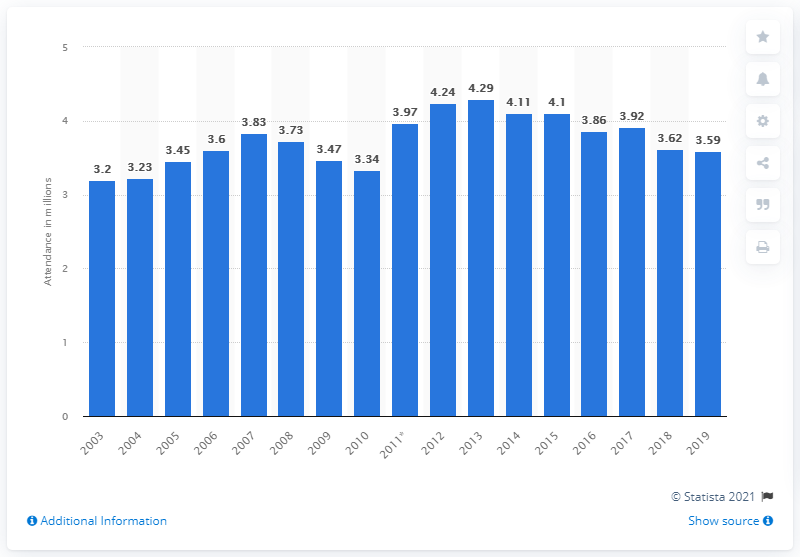Outline some significant characteristics in this image. In the 2019 Pac-12 Conference season, a total of 78 games were attended by 3,590 spectators on average. 